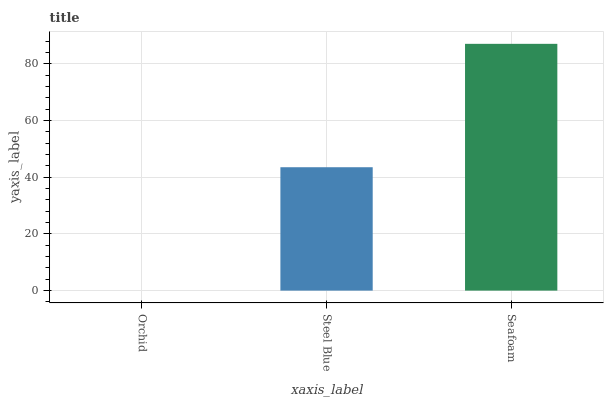Is Orchid the minimum?
Answer yes or no. Yes. Is Seafoam the maximum?
Answer yes or no. Yes. Is Steel Blue the minimum?
Answer yes or no. No. Is Steel Blue the maximum?
Answer yes or no. No. Is Steel Blue greater than Orchid?
Answer yes or no. Yes. Is Orchid less than Steel Blue?
Answer yes or no. Yes. Is Orchid greater than Steel Blue?
Answer yes or no. No. Is Steel Blue less than Orchid?
Answer yes or no. No. Is Steel Blue the high median?
Answer yes or no. Yes. Is Steel Blue the low median?
Answer yes or no. Yes. Is Orchid the high median?
Answer yes or no. No. Is Orchid the low median?
Answer yes or no. No. 